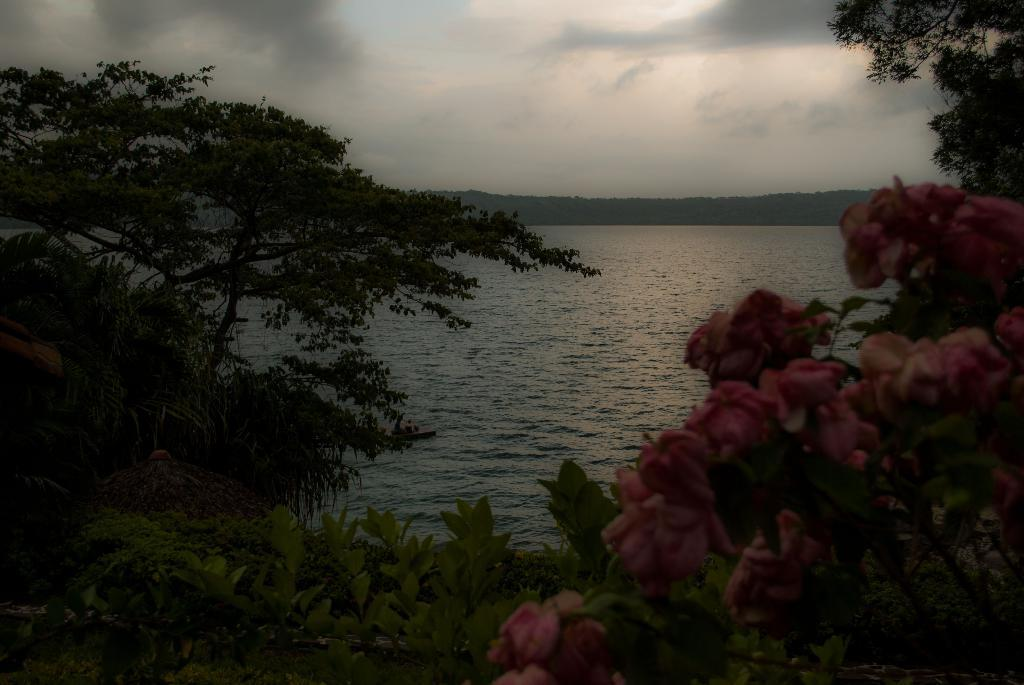What type of vegetation is located at the front of the image? There are flowers in the front of the image. What can be seen in the center of the image? There are plants and trees in the center of the image. What is visible in the background of the image? There is a sea in the background of the image. How would you describe the sky in the background of the image? The sky is cloudy in the background of the image. What type of blade is being used to trim the trees in the image? There is no blade visible in the image, and no tree trimming is taking place. Are there any gloves present in the image? There is no mention of gloves in the provided facts, and no gloves are visible in the image. 